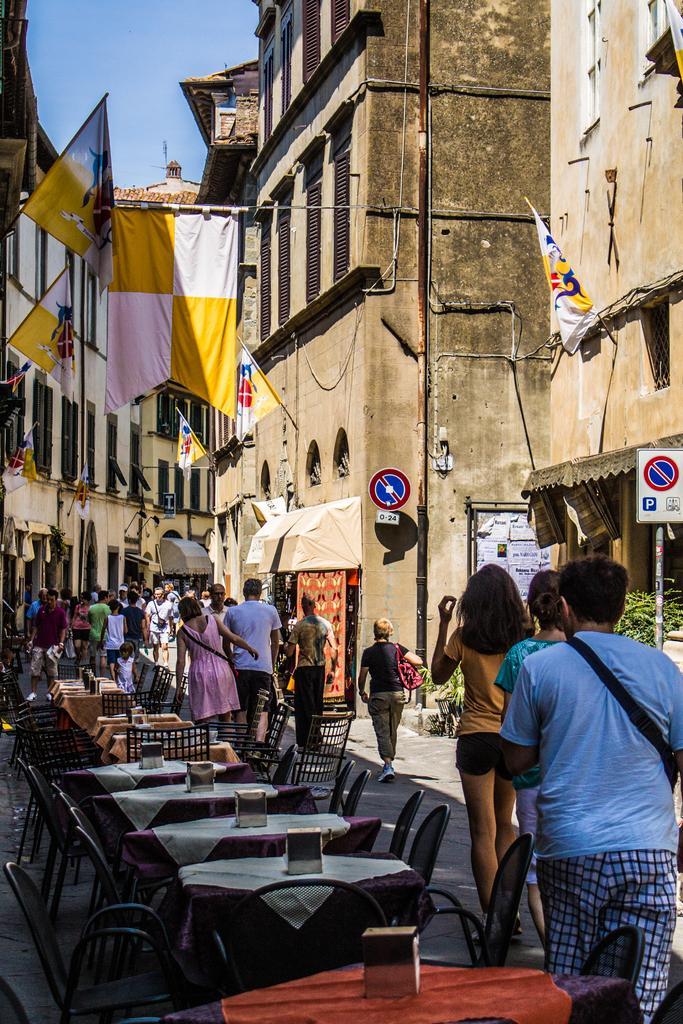How would you summarize this image in a sentence or two? In this image we can see a few people who are walking on the road. Here we can see a table and chair arrangement on the left side. Here we can see flags and buildings. 